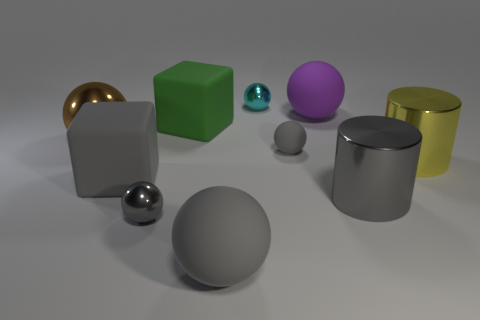Subtract all brown spheres. How many spheres are left? 5 Subtract all gray blocks. How many gray balls are left? 3 Subtract all purple spheres. How many spheres are left? 5 Subtract all spheres. How many objects are left? 4 Subtract 0 cyan cylinders. How many objects are left? 10 Subtract all yellow cubes. Subtract all blue cylinders. How many cubes are left? 2 Subtract all cylinders. Subtract all purple objects. How many objects are left? 7 Add 2 gray things. How many gray things are left? 7 Add 7 gray matte spheres. How many gray matte spheres exist? 9 